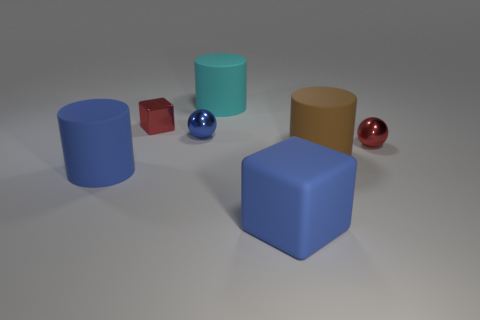There is a cyan thing that is the same material as the large block; what shape is it?
Provide a short and direct response. Cylinder. Does the brown rubber cylinder have the same size as the blue metallic thing?
Ensure brevity in your answer.  No. What number of objects are either large objects that are to the right of the blue rubber cylinder or red things right of the small blue sphere?
Offer a very short reply. 4. There is a big blue matte thing in front of the big thing to the left of the small red cube; how many balls are on the left side of it?
Your response must be concise. 1. How big is the blue thing behind the brown cylinder?
Offer a terse response. Small. How many brown things are the same size as the red metal block?
Give a very brief answer. 0. There is a cyan matte thing; is its size the same as the blue matte thing that is behind the large rubber block?
Your response must be concise. Yes. What number of things are either red metallic objects or small brown rubber balls?
Your answer should be very brief. 2. How many small matte cylinders have the same color as the big cube?
Offer a terse response. 0. There is a brown matte thing that is the same size as the cyan thing; what shape is it?
Give a very brief answer. Cylinder. 